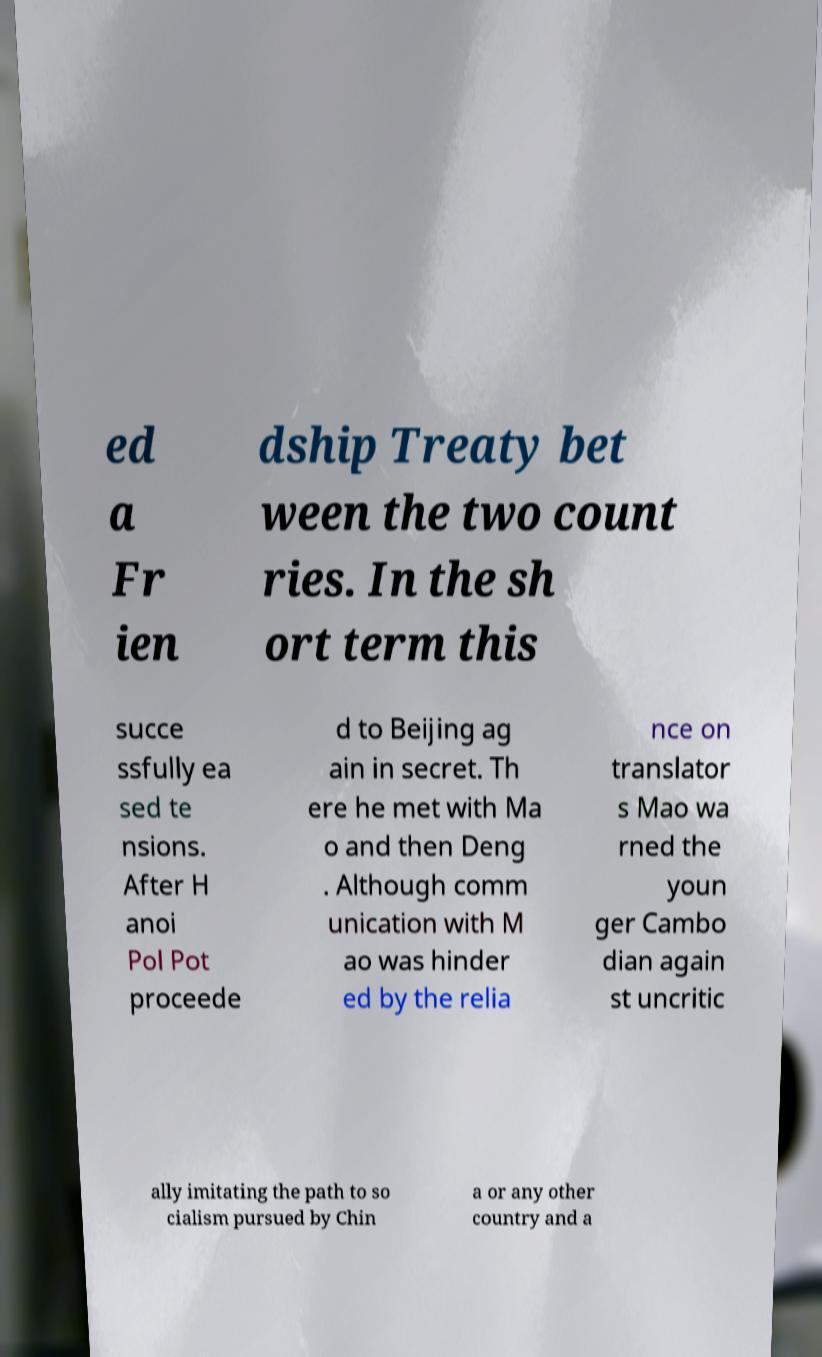Please identify and transcribe the text found in this image. ed a Fr ien dship Treaty bet ween the two count ries. In the sh ort term this succe ssfully ea sed te nsions. After H anoi Pol Pot proceede d to Beijing ag ain in secret. Th ere he met with Ma o and then Deng . Although comm unication with M ao was hinder ed by the relia nce on translator s Mao wa rned the youn ger Cambo dian again st uncritic ally imitating the path to so cialism pursued by Chin a or any other country and a 